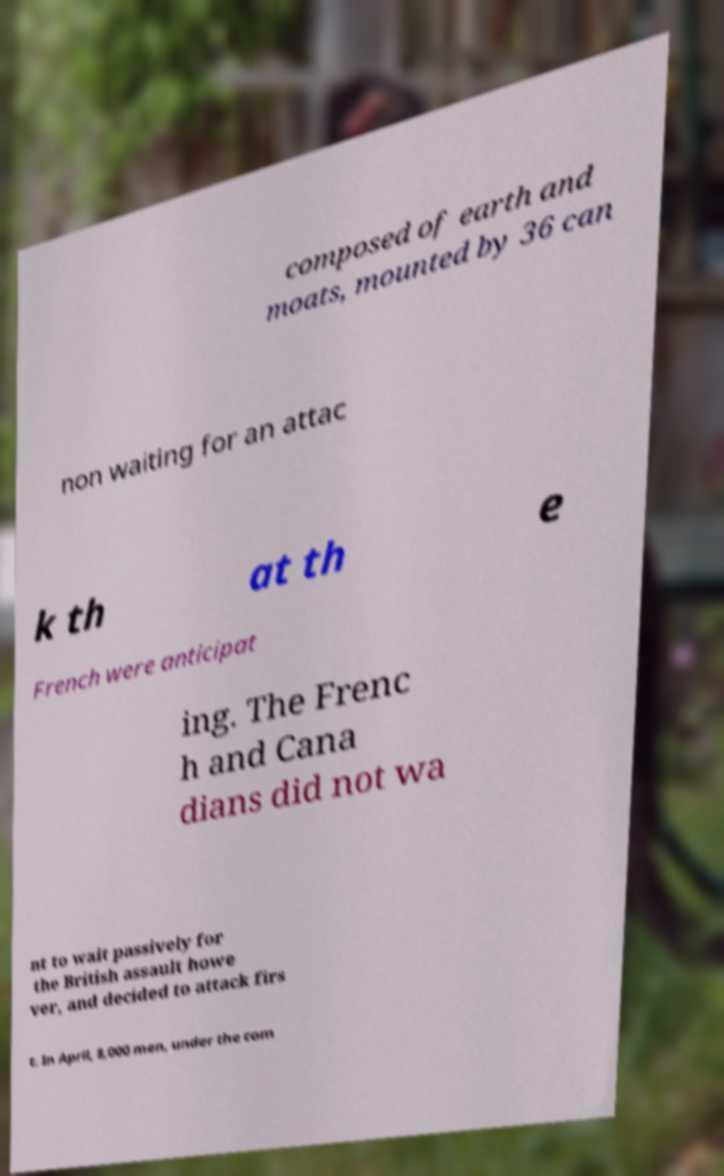For documentation purposes, I need the text within this image transcribed. Could you provide that? composed of earth and moats, mounted by 36 can non waiting for an attac k th at th e French were anticipat ing. The Frenc h and Cana dians did not wa nt to wait passively for the British assault howe ver, and decided to attack firs t. In April, 8,000 men, under the com 